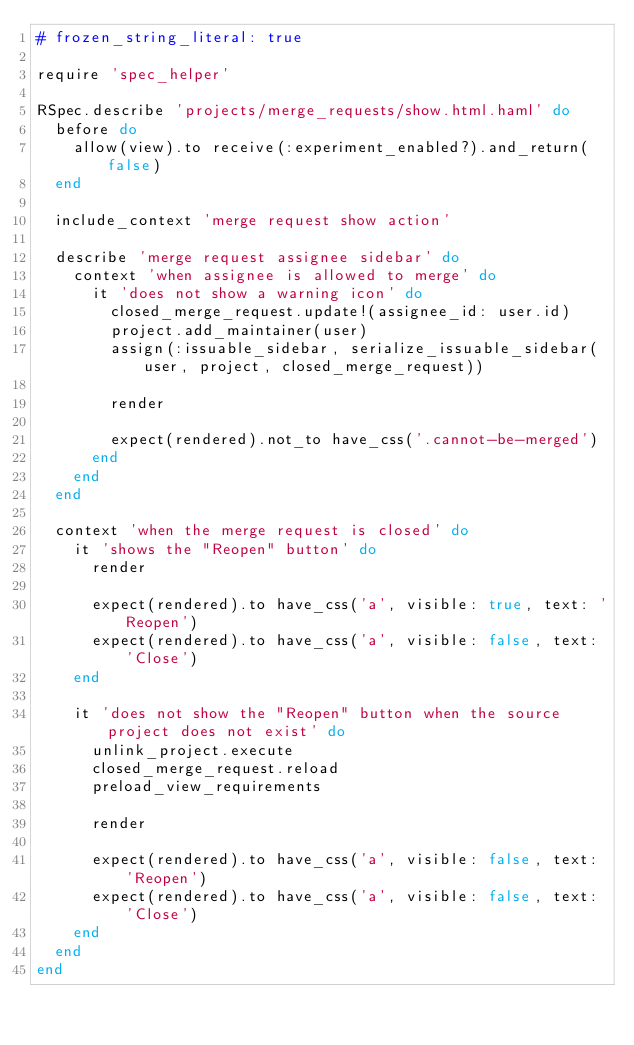Convert code to text. <code><loc_0><loc_0><loc_500><loc_500><_Ruby_># frozen_string_literal: true

require 'spec_helper'

RSpec.describe 'projects/merge_requests/show.html.haml' do
  before do
    allow(view).to receive(:experiment_enabled?).and_return(false)
  end

  include_context 'merge request show action'

  describe 'merge request assignee sidebar' do
    context 'when assignee is allowed to merge' do
      it 'does not show a warning icon' do
        closed_merge_request.update!(assignee_id: user.id)
        project.add_maintainer(user)
        assign(:issuable_sidebar, serialize_issuable_sidebar(user, project, closed_merge_request))

        render

        expect(rendered).not_to have_css('.cannot-be-merged')
      end
    end
  end

  context 'when the merge request is closed' do
    it 'shows the "Reopen" button' do
      render

      expect(rendered).to have_css('a', visible: true, text: 'Reopen')
      expect(rendered).to have_css('a', visible: false, text: 'Close')
    end

    it 'does not show the "Reopen" button when the source project does not exist' do
      unlink_project.execute
      closed_merge_request.reload
      preload_view_requirements

      render

      expect(rendered).to have_css('a', visible: false, text: 'Reopen')
      expect(rendered).to have_css('a', visible: false, text: 'Close')
    end
  end
end
</code> 